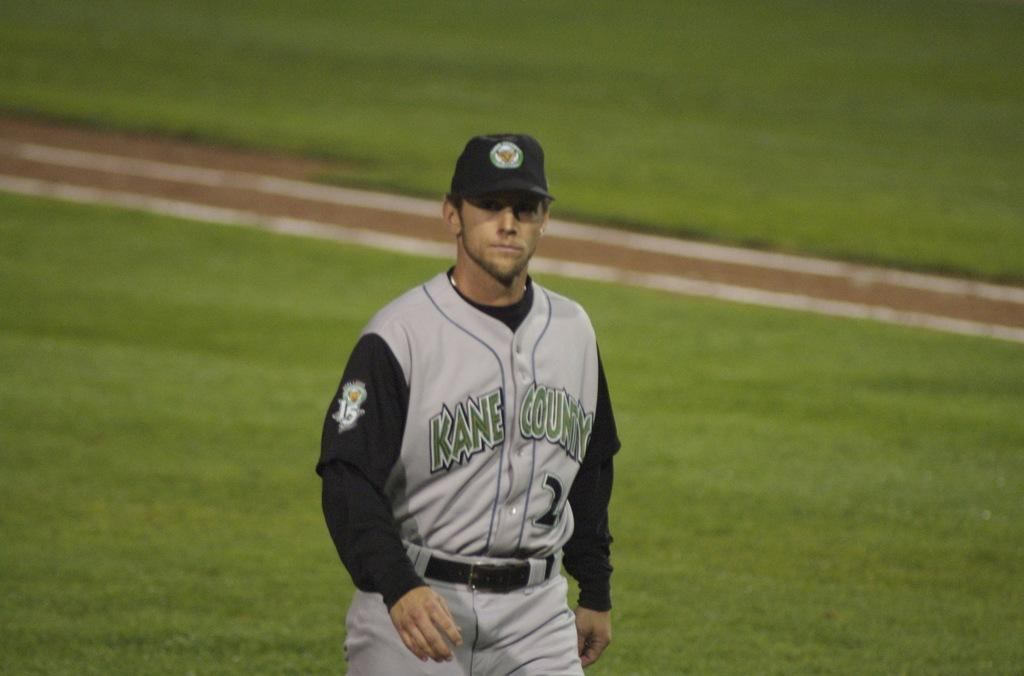<image>
Share a concise interpretation of the image provided. A baseball player, wearing a Kane County jersey, walks across the field. 